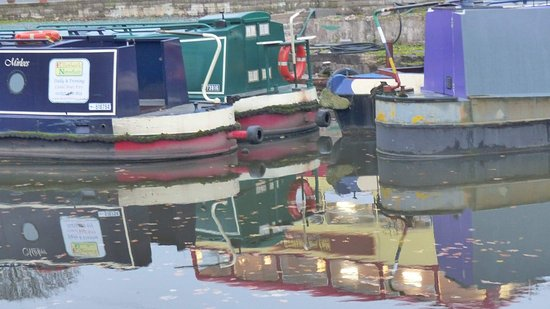How many boats are there in the image? There are a total of three boats visible in the image, each with its own distinct color and moored side by side, reflecting a vibrant scene on the water. 